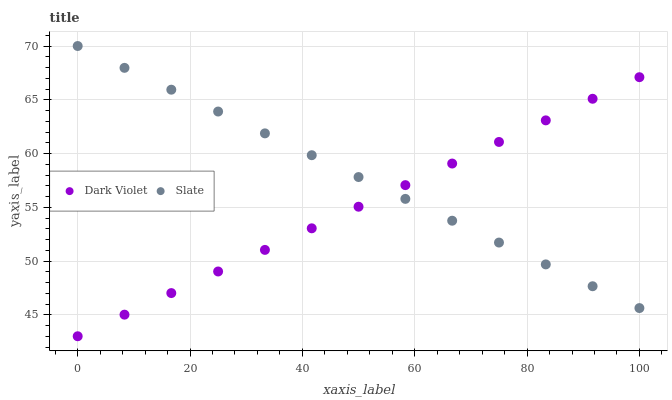Does Dark Violet have the minimum area under the curve?
Answer yes or no. Yes. Does Slate have the maximum area under the curve?
Answer yes or no. Yes. Does Dark Violet have the maximum area under the curve?
Answer yes or no. No. Is Dark Violet the smoothest?
Answer yes or no. Yes. Is Slate the roughest?
Answer yes or no. Yes. Is Dark Violet the roughest?
Answer yes or no. No. Does Dark Violet have the lowest value?
Answer yes or no. Yes. Does Slate have the highest value?
Answer yes or no. Yes. Does Dark Violet have the highest value?
Answer yes or no. No. Does Dark Violet intersect Slate?
Answer yes or no. Yes. Is Dark Violet less than Slate?
Answer yes or no. No. Is Dark Violet greater than Slate?
Answer yes or no. No. 